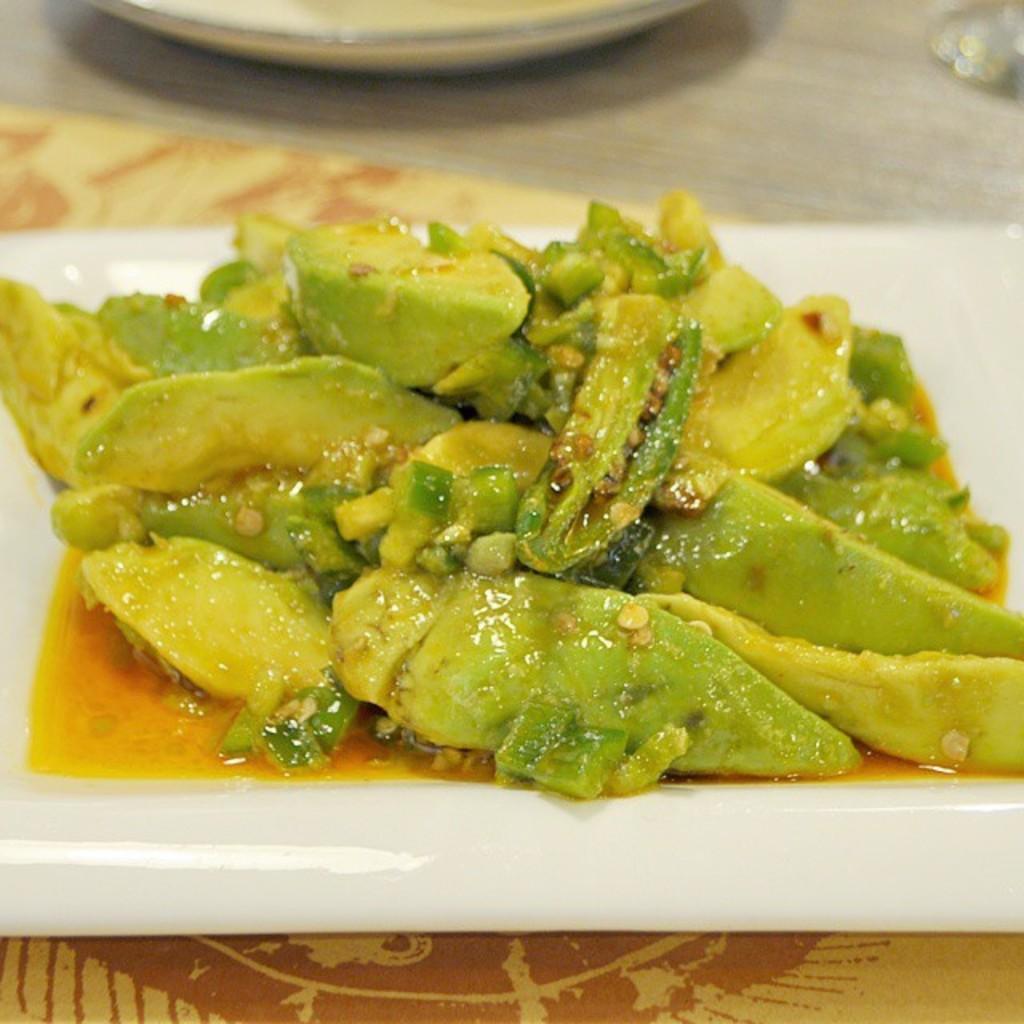Describe this image in one or two sentences. In this picture we can see some food item which is in white color plate, is on the surface of a table. 